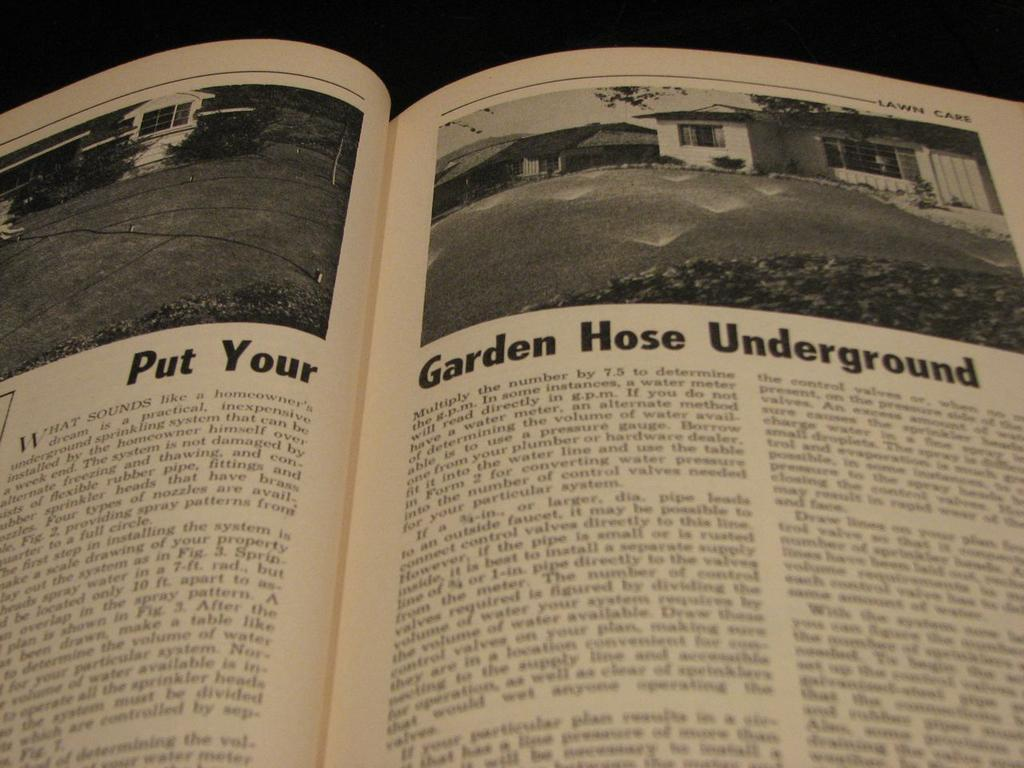Provide a one-sentence caption for the provided image. A lawn care book is open to a page advising you to Put Your Garden Hose Underground. 